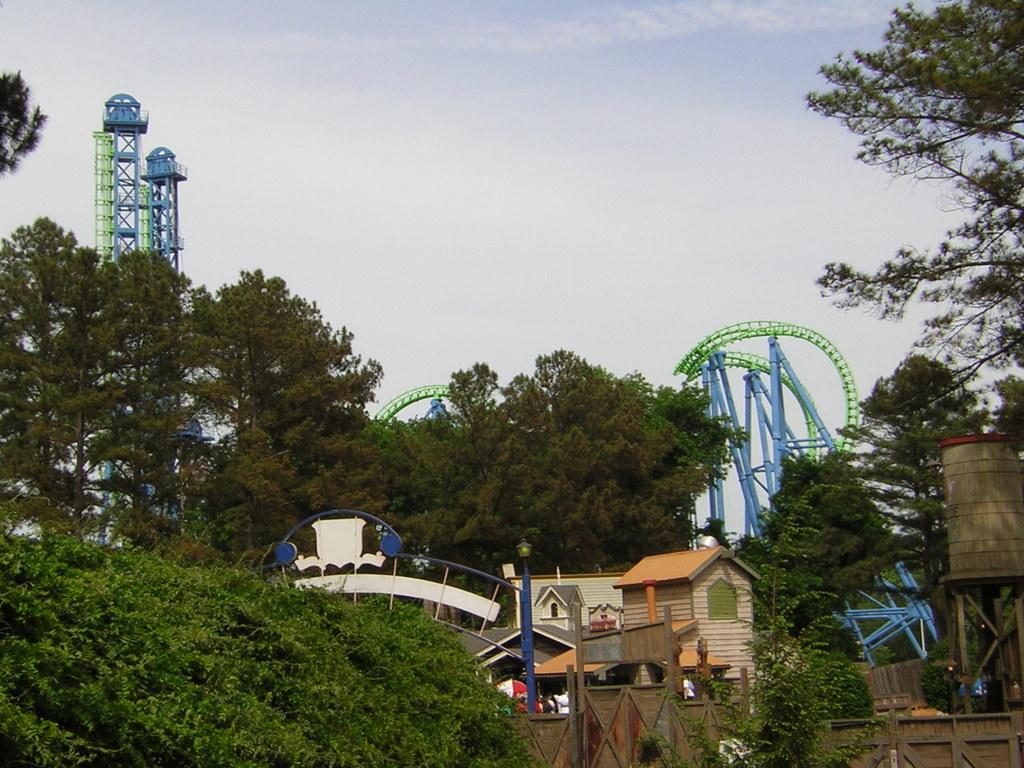What is located in the foreground of the image? In the foreground of the image, there is a fence, plants, trees, houses, a board, poles, and metal objects. Can you describe the objects in the foreground? The fence is made of metal, the plants are green, the trees are tall, the houses are residential, the board is likely for displaying information, the poles are vertical supports, and the metal objects are unspecified. What can be seen in the background of the image? In the background of the image, there are towers and the sky. What is the time of day in the image? The image might have been taken during the day, as indicated by the visible sky. What type of business is being conducted in the image? There is no indication of any business activity in the image. Can you describe the arch in the image? There is no arch present in the image. What type of chess pieces can be seen on the board in the image? There is no board game or chess pieces visible in the image. 